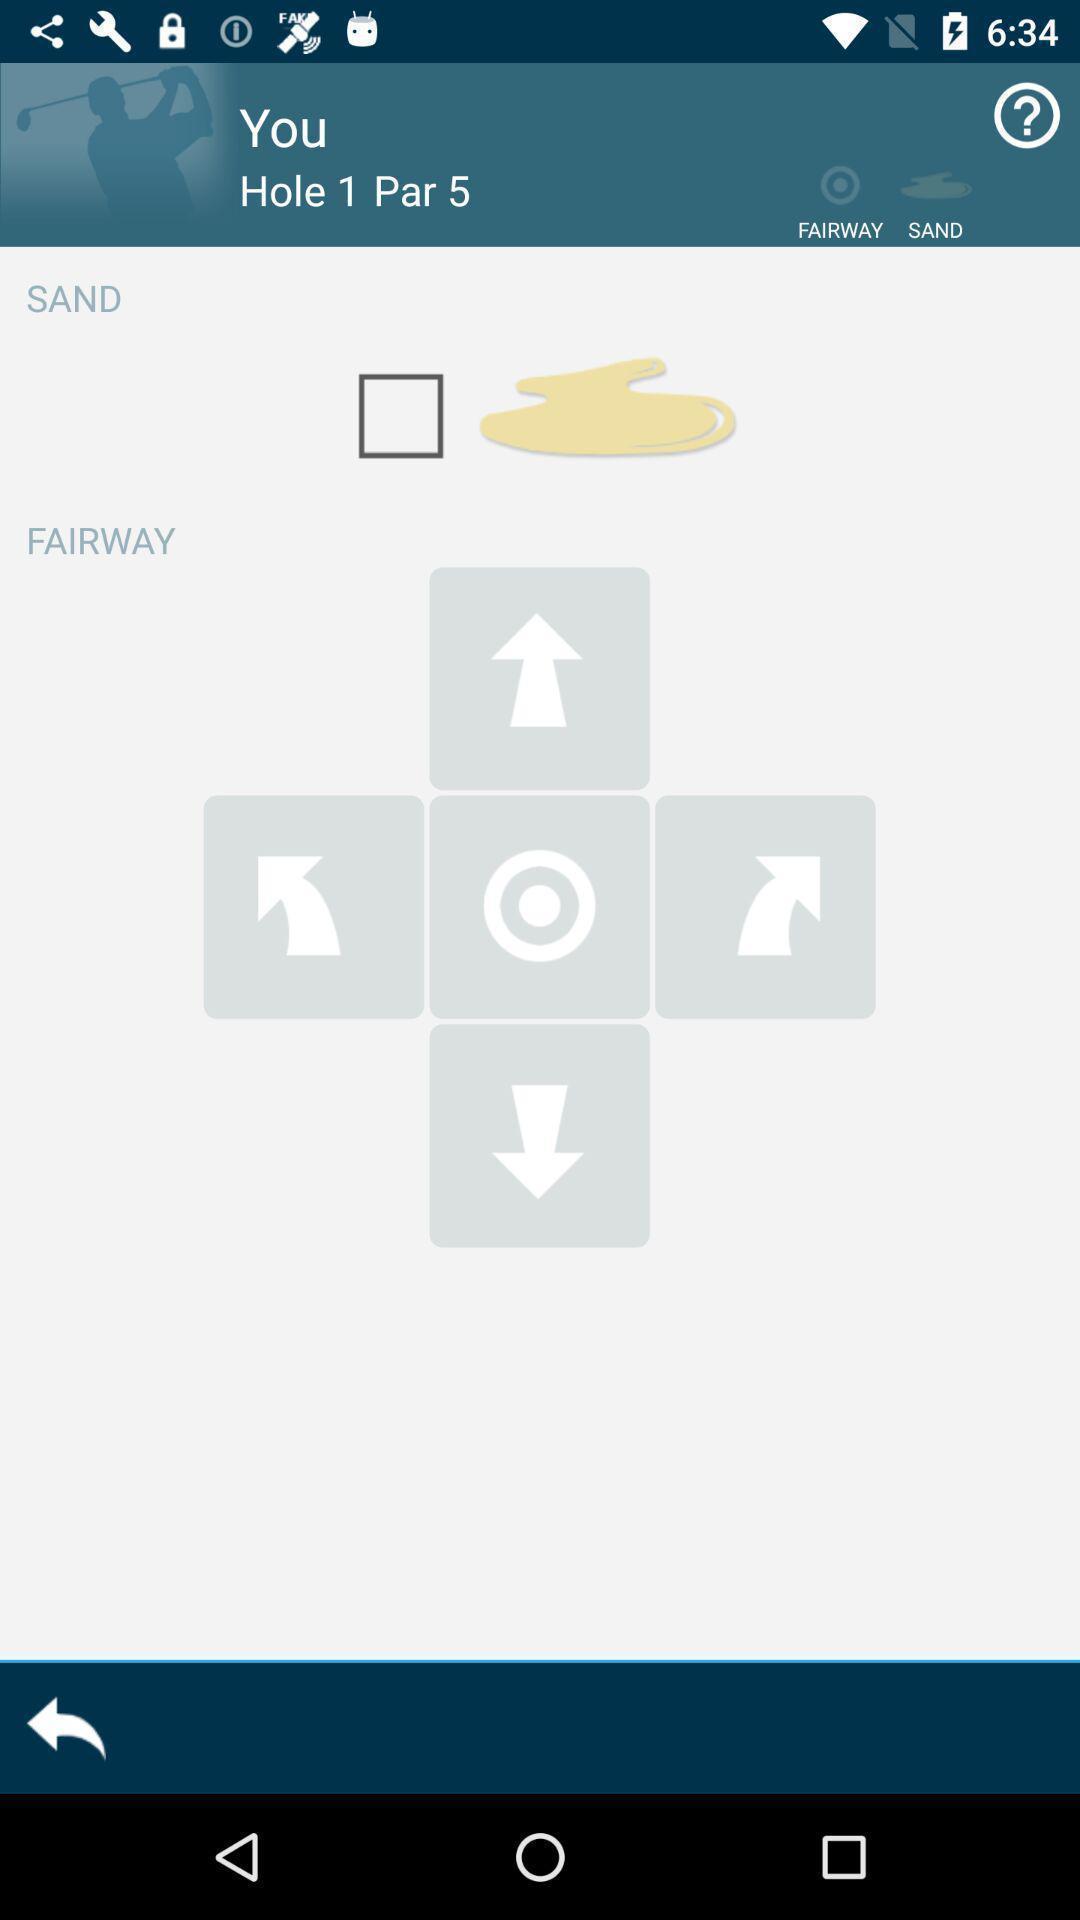Explain what's happening in this screen capture. Sand and fair way of the app. 